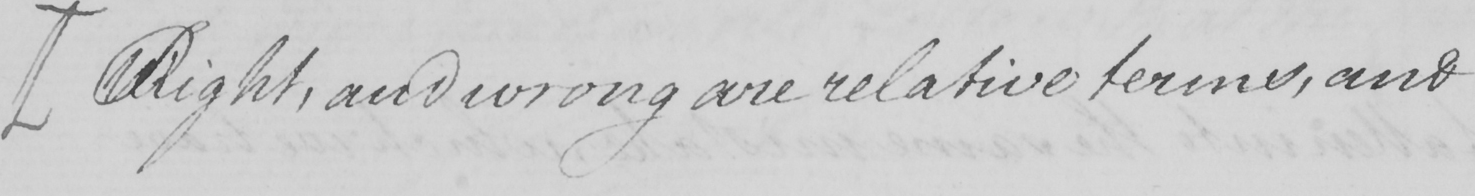Please provide the text content of this handwritten line. [ Right , and wrong are relative terms , and 